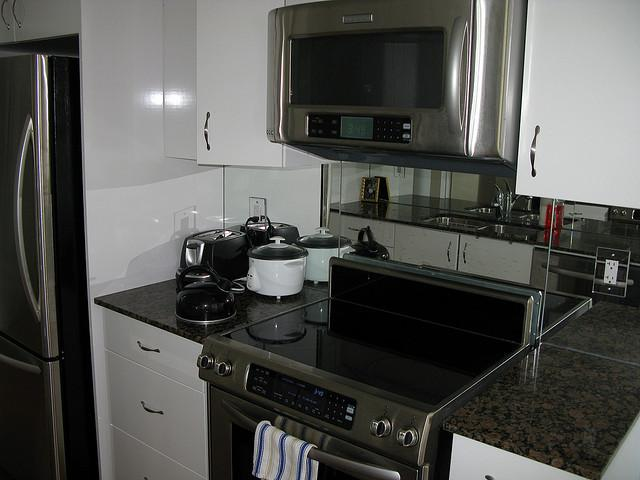What is the white cooker called?

Choices:
A) rice cooker
B) dutch oven
C) air fryer
D) ninja rice cooker 